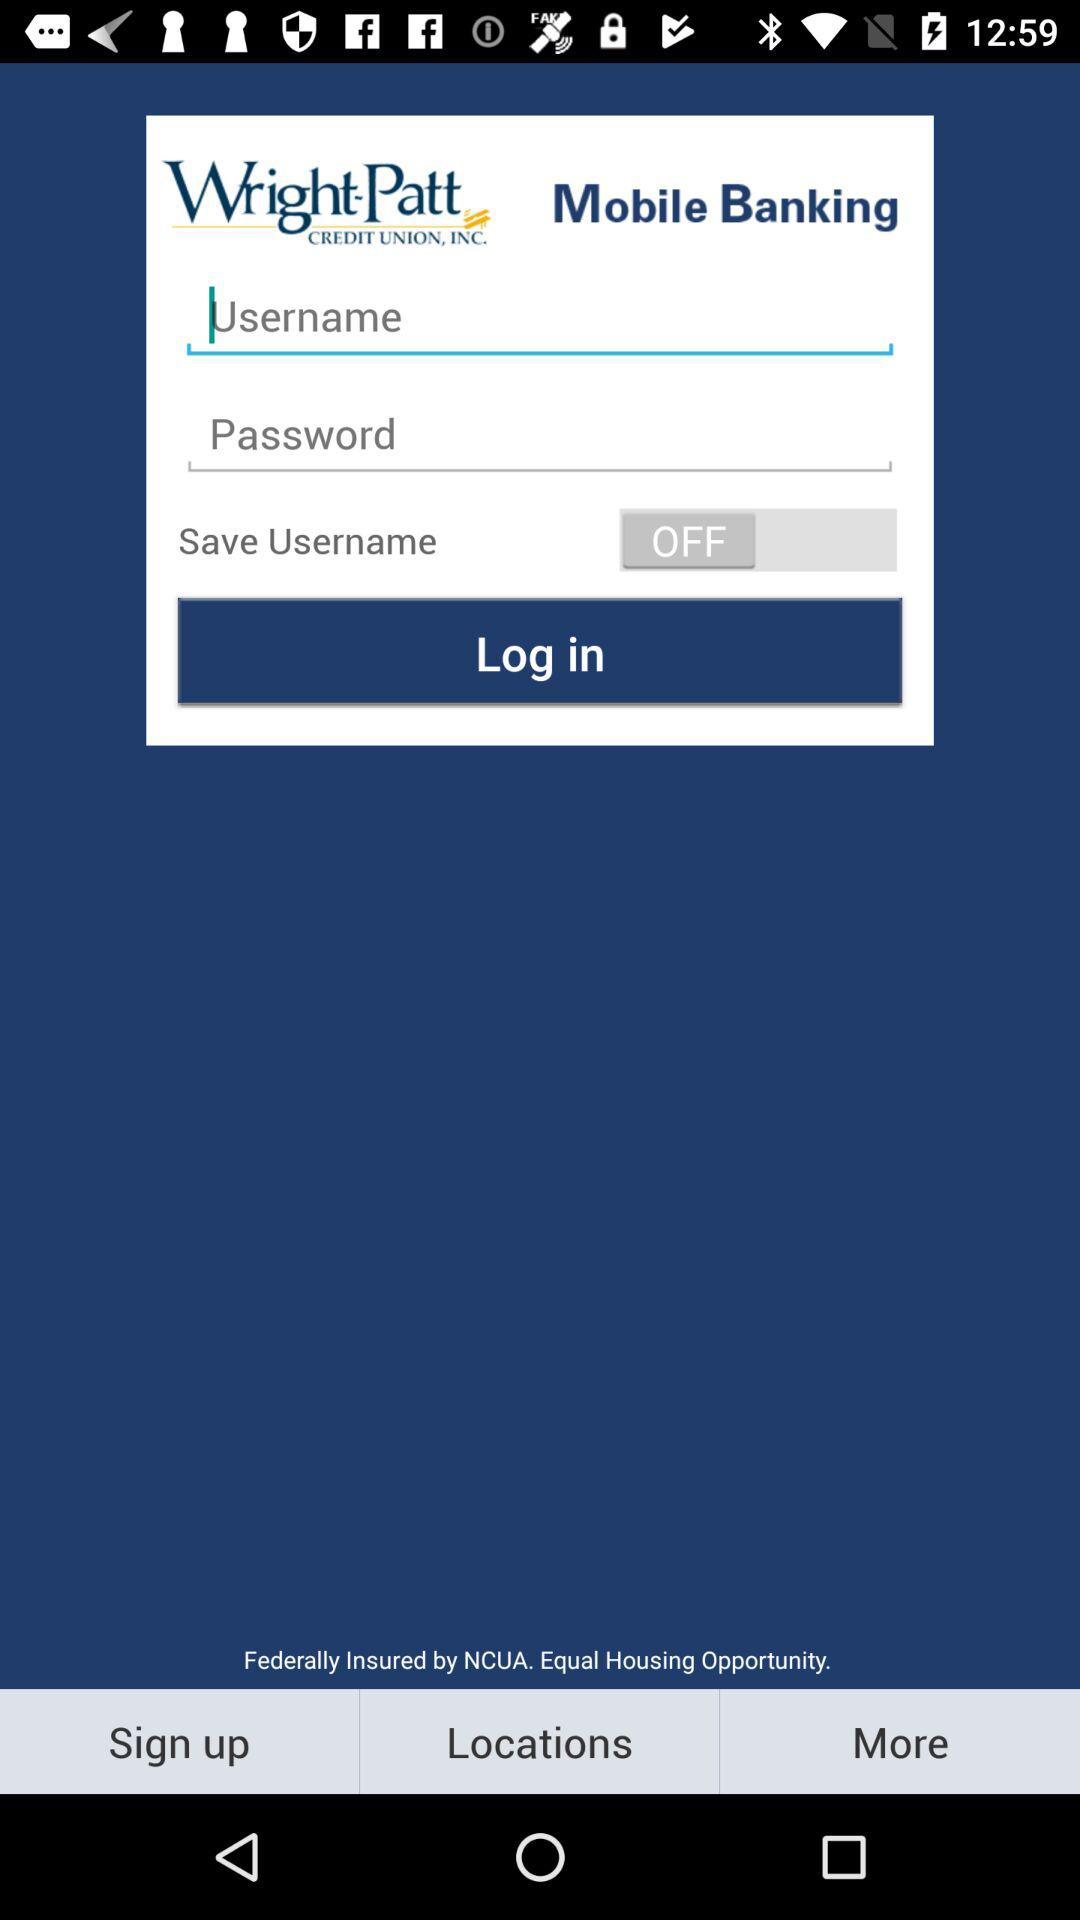How many text inputs are required to log in?
Answer the question using a single word or phrase. 2 